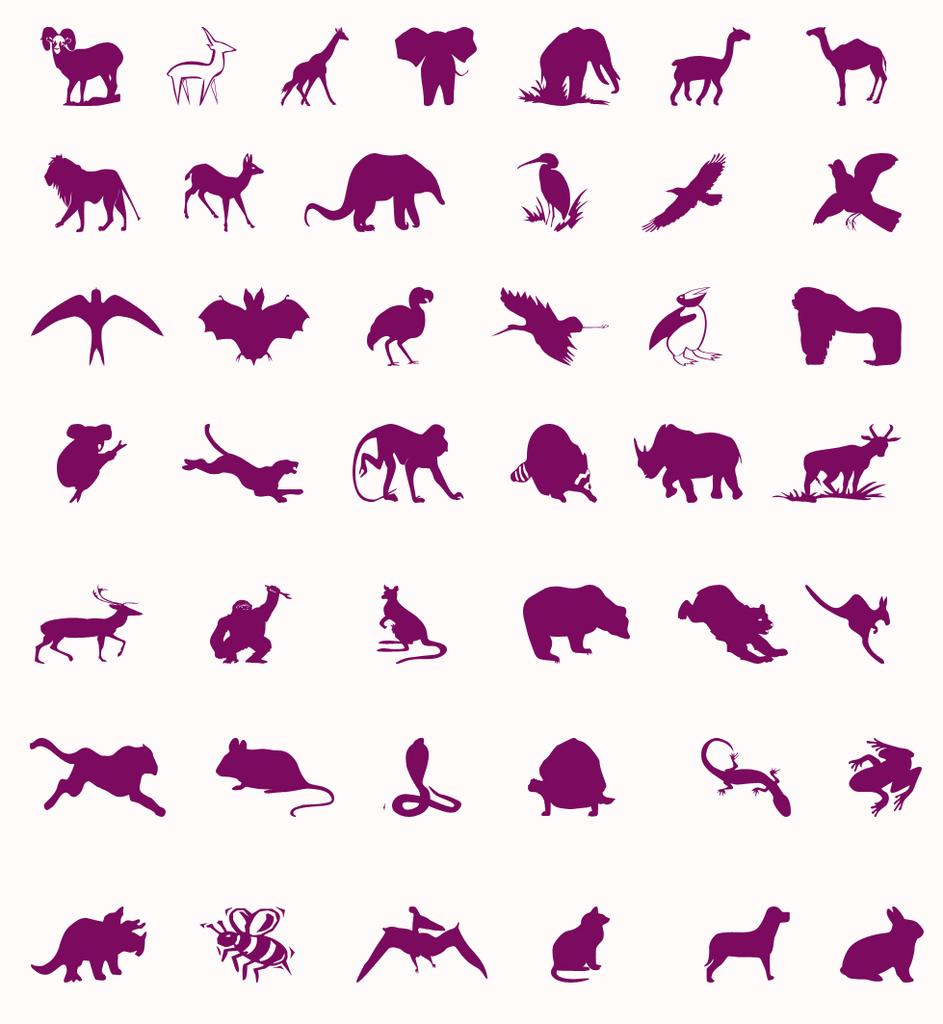What types of creatures can be seen in the image? There are different kinds of birds and animals in the image. Can you describe the birds in the image? The image contains different kinds of birds, but their specific characteristics are not mentioned in the facts. What other types of animals are present in the image besides birds? The facts mention that there are different kinds of animals in the image, but their specific characteristics are not mentioned. What type of hand can be seen holding a goldfish in the image? There is no hand or goldfish present in the image; it only contains different kinds of birds and animals. 